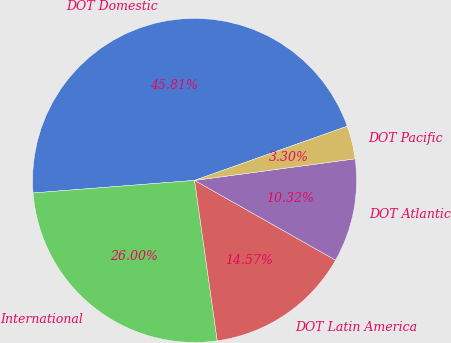Convert chart. <chart><loc_0><loc_0><loc_500><loc_500><pie_chart><fcel>DOT Domestic<fcel>International<fcel>DOT Latin America<fcel>DOT Atlantic<fcel>DOT Pacific<nl><fcel>45.81%<fcel>26.0%<fcel>14.57%<fcel>10.32%<fcel>3.3%<nl></chart> 